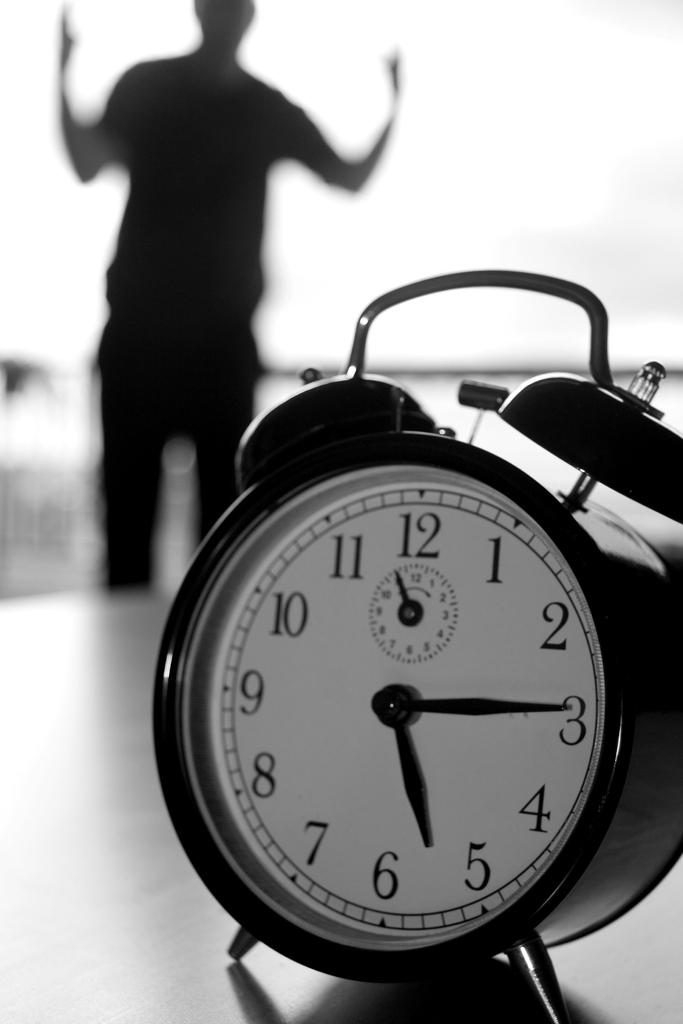What time is it?
Your answer should be very brief. 5:14. 